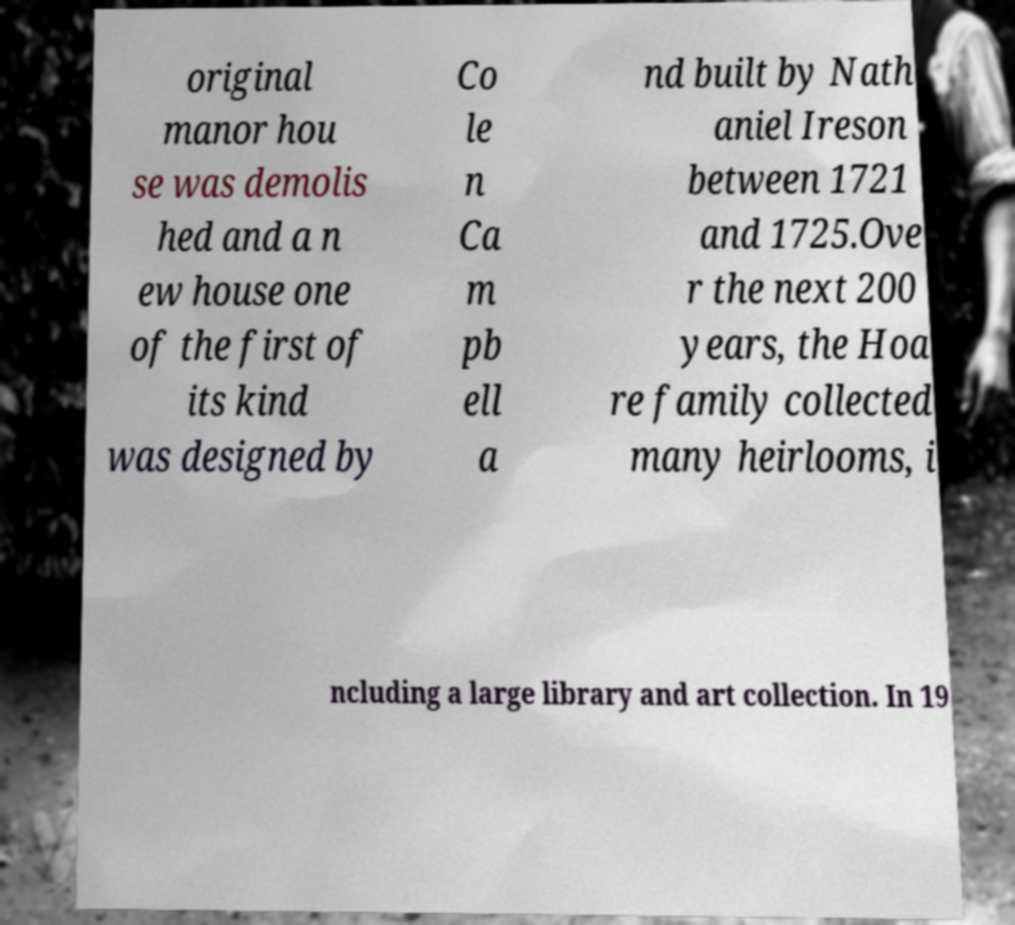Please read and relay the text visible in this image. What does it say? original manor hou se was demolis hed and a n ew house one of the first of its kind was designed by Co le n Ca m pb ell a nd built by Nath aniel Ireson between 1721 and 1725.Ove r the next 200 years, the Hoa re family collected many heirlooms, i ncluding a large library and art collection. In 19 